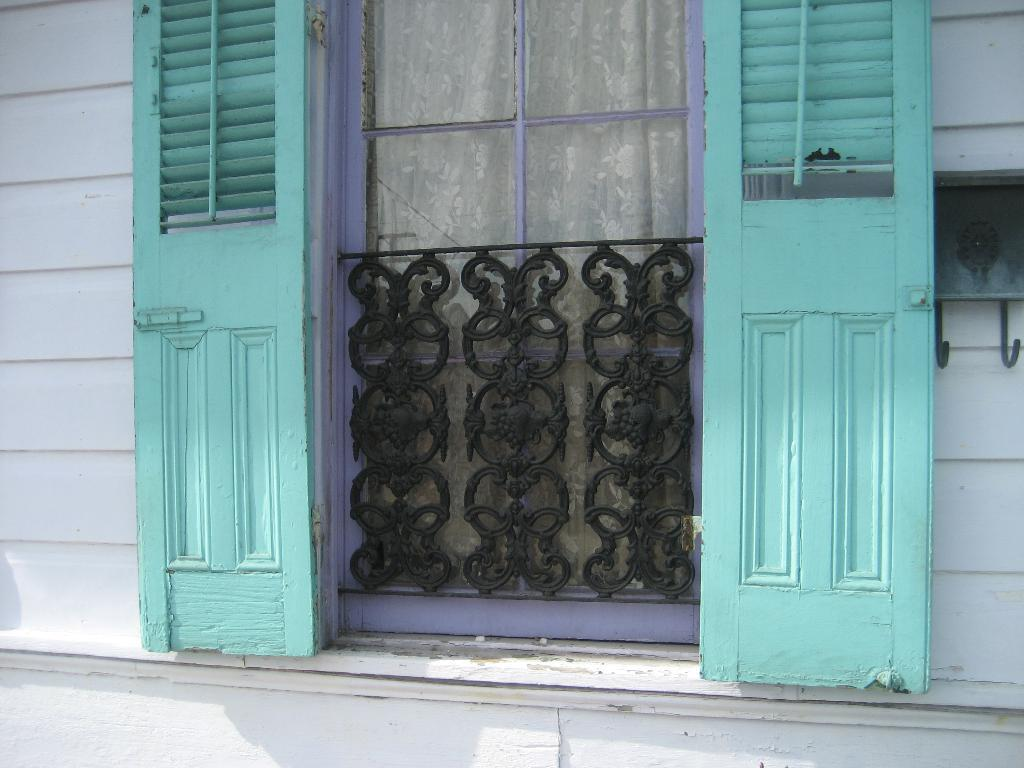What is located in the center of the image? There is a window and a grill in the center of the image. What is associated with the window? There is a curtain associated with the window. What type of structure can be seen in the image? There is a brick wall in the image. What object is located towards the right side of the image? There is a hanger towards the right side of the image. What is at the bottom of the image? There is a well at the bottom of the image. How many sheep are present in the image? There are no sheep present in the image. What is the level of disgust in the image? The image does not convey any emotions or feelings, including disgust. 